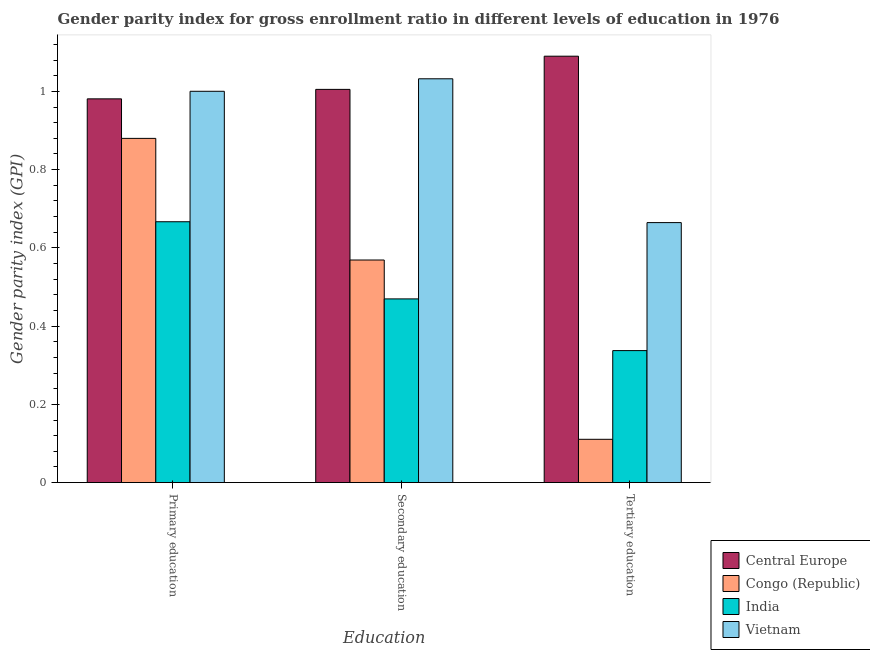Are the number of bars on each tick of the X-axis equal?
Make the answer very short. Yes. How many bars are there on the 1st tick from the right?
Offer a very short reply. 4. What is the label of the 3rd group of bars from the left?
Make the answer very short. Tertiary education. What is the gender parity index in tertiary education in Central Europe?
Ensure brevity in your answer.  1.09. Across all countries, what is the maximum gender parity index in tertiary education?
Make the answer very short. 1.09. Across all countries, what is the minimum gender parity index in primary education?
Offer a terse response. 0.67. In which country was the gender parity index in primary education maximum?
Provide a short and direct response. Vietnam. In which country was the gender parity index in secondary education minimum?
Your answer should be very brief. India. What is the total gender parity index in tertiary education in the graph?
Make the answer very short. 2.2. What is the difference between the gender parity index in tertiary education in Central Europe and that in Congo (Republic)?
Your answer should be very brief. 0.98. What is the difference between the gender parity index in secondary education in Congo (Republic) and the gender parity index in primary education in India?
Provide a succinct answer. -0.1. What is the average gender parity index in primary education per country?
Provide a short and direct response. 0.88. What is the difference between the gender parity index in tertiary education and gender parity index in secondary education in Congo (Republic)?
Provide a succinct answer. -0.46. In how many countries, is the gender parity index in tertiary education greater than 0.32 ?
Ensure brevity in your answer.  3. What is the ratio of the gender parity index in secondary education in Vietnam to that in Central Europe?
Your answer should be very brief. 1.03. What is the difference between the highest and the second highest gender parity index in tertiary education?
Your answer should be very brief. 0.43. What is the difference between the highest and the lowest gender parity index in secondary education?
Your response must be concise. 0.56. In how many countries, is the gender parity index in tertiary education greater than the average gender parity index in tertiary education taken over all countries?
Your response must be concise. 2. What does the 1st bar from the left in Tertiary education represents?
Provide a succinct answer. Central Europe. How many bars are there?
Keep it short and to the point. 12. How many countries are there in the graph?
Your response must be concise. 4. What is the difference between two consecutive major ticks on the Y-axis?
Offer a terse response. 0.2. What is the title of the graph?
Make the answer very short. Gender parity index for gross enrollment ratio in different levels of education in 1976. Does "Burundi" appear as one of the legend labels in the graph?
Offer a terse response. No. What is the label or title of the X-axis?
Offer a terse response. Education. What is the label or title of the Y-axis?
Your answer should be compact. Gender parity index (GPI). What is the Gender parity index (GPI) in Central Europe in Primary education?
Offer a terse response. 0.98. What is the Gender parity index (GPI) in Congo (Republic) in Primary education?
Provide a succinct answer. 0.88. What is the Gender parity index (GPI) in India in Primary education?
Make the answer very short. 0.67. What is the Gender parity index (GPI) of Vietnam in Primary education?
Make the answer very short. 1. What is the Gender parity index (GPI) in Central Europe in Secondary education?
Ensure brevity in your answer.  1.01. What is the Gender parity index (GPI) of Congo (Republic) in Secondary education?
Provide a short and direct response. 0.57. What is the Gender parity index (GPI) in India in Secondary education?
Provide a succinct answer. 0.47. What is the Gender parity index (GPI) of Vietnam in Secondary education?
Give a very brief answer. 1.03. What is the Gender parity index (GPI) in Central Europe in Tertiary education?
Keep it short and to the point. 1.09. What is the Gender parity index (GPI) in Congo (Republic) in Tertiary education?
Provide a succinct answer. 0.11. What is the Gender parity index (GPI) in India in Tertiary education?
Provide a succinct answer. 0.34. What is the Gender parity index (GPI) in Vietnam in Tertiary education?
Your response must be concise. 0.66. Across all Education, what is the maximum Gender parity index (GPI) in Central Europe?
Give a very brief answer. 1.09. Across all Education, what is the maximum Gender parity index (GPI) in Congo (Republic)?
Provide a short and direct response. 0.88. Across all Education, what is the maximum Gender parity index (GPI) of India?
Provide a short and direct response. 0.67. Across all Education, what is the maximum Gender parity index (GPI) of Vietnam?
Your answer should be very brief. 1.03. Across all Education, what is the minimum Gender parity index (GPI) in Central Europe?
Make the answer very short. 0.98. Across all Education, what is the minimum Gender parity index (GPI) in Congo (Republic)?
Give a very brief answer. 0.11. Across all Education, what is the minimum Gender parity index (GPI) of India?
Provide a short and direct response. 0.34. Across all Education, what is the minimum Gender parity index (GPI) in Vietnam?
Provide a short and direct response. 0.66. What is the total Gender parity index (GPI) in Central Europe in the graph?
Your answer should be compact. 3.08. What is the total Gender parity index (GPI) in Congo (Republic) in the graph?
Make the answer very short. 1.56. What is the total Gender parity index (GPI) in India in the graph?
Give a very brief answer. 1.47. What is the total Gender parity index (GPI) of Vietnam in the graph?
Keep it short and to the point. 2.7. What is the difference between the Gender parity index (GPI) in Central Europe in Primary education and that in Secondary education?
Your answer should be compact. -0.02. What is the difference between the Gender parity index (GPI) in Congo (Republic) in Primary education and that in Secondary education?
Offer a very short reply. 0.31. What is the difference between the Gender parity index (GPI) in India in Primary education and that in Secondary education?
Provide a succinct answer. 0.2. What is the difference between the Gender parity index (GPI) of Vietnam in Primary education and that in Secondary education?
Keep it short and to the point. -0.03. What is the difference between the Gender parity index (GPI) of Central Europe in Primary education and that in Tertiary education?
Offer a terse response. -0.11. What is the difference between the Gender parity index (GPI) in Congo (Republic) in Primary education and that in Tertiary education?
Offer a terse response. 0.77. What is the difference between the Gender parity index (GPI) in India in Primary education and that in Tertiary education?
Offer a terse response. 0.33. What is the difference between the Gender parity index (GPI) of Vietnam in Primary education and that in Tertiary education?
Your response must be concise. 0.34. What is the difference between the Gender parity index (GPI) of Central Europe in Secondary education and that in Tertiary education?
Provide a short and direct response. -0.08. What is the difference between the Gender parity index (GPI) in Congo (Republic) in Secondary education and that in Tertiary education?
Your response must be concise. 0.46. What is the difference between the Gender parity index (GPI) in India in Secondary education and that in Tertiary education?
Offer a very short reply. 0.13. What is the difference between the Gender parity index (GPI) of Vietnam in Secondary education and that in Tertiary education?
Your response must be concise. 0.37. What is the difference between the Gender parity index (GPI) in Central Europe in Primary education and the Gender parity index (GPI) in Congo (Republic) in Secondary education?
Provide a succinct answer. 0.41. What is the difference between the Gender parity index (GPI) in Central Europe in Primary education and the Gender parity index (GPI) in India in Secondary education?
Provide a succinct answer. 0.51. What is the difference between the Gender parity index (GPI) in Central Europe in Primary education and the Gender parity index (GPI) in Vietnam in Secondary education?
Provide a short and direct response. -0.05. What is the difference between the Gender parity index (GPI) in Congo (Republic) in Primary education and the Gender parity index (GPI) in India in Secondary education?
Give a very brief answer. 0.41. What is the difference between the Gender parity index (GPI) of Congo (Republic) in Primary education and the Gender parity index (GPI) of Vietnam in Secondary education?
Provide a short and direct response. -0.15. What is the difference between the Gender parity index (GPI) of India in Primary education and the Gender parity index (GPI) of Vietnam in Secondary education?
Offer a terse response. -0.37. What is the difference between the Gender parity index (GPI) of Central Europe in Primary education and the Gender parity index (GPI) of Congo (Republic) in Tertiary education?
Your answer should be very brief. 0.87. What is the difference between the Gender parity index (GPI) of Central Europe in Primary education and the Gender parity index (GPI) of India in Tertiary education?
Offer a terse response. 0.64. What is the difference between the Gender parity index (GPI) of Central Europe in Primary education and the Gender parity index (GPI) of Vietnam in Tertiary education?
Your answer should be very brief. 0.32. What is the difference between the Gender parity index (GPI) in Congo (Republic) in Primary education and the Gender parity index (GPI) in India in Tertiary education?
Keep it short and to the point. 0.54. What is the difference between the Gender parity index (GPI) of Congo (Republic) in Primary education and the Gender parity index (GPI) of Vietnam in Tertiary education?
Provide a succinct answer. 0.22. What is the difference between the Gender parity index (GPI) of India in Primary education and the Gender parity index (GPI) of Vietnam in Tertiary education?
Provide a short and direct response. 0. What is the difference between the Gender parity index (GPI) in Central Europe in Secondary education and the Gender parity index (GPI) in Congo (Republic) in Tertiary education?
Offer a terse response. 0.89. What is the difference between the Gender parity index (GPI) of Central Europe in Secondary education and the Gender parity index (GPI) of India in Tertiary education?
Provide a short and direct response. 0.67. What is the difference between the Gender parity index (GPI) in Central Europe in Secondary education and the Gender parity index (GPI) in Vietnam in Tertiary education?
Make the answer very short. 0.34. What is the difference between the Gender parity index (GPI) of Congo (Republic) in Secondary education and the Gender parity index (GPI) of India in Tertiary education?
Offer a very short reply. 0.23. What is the difference between the Gender parity index (GPI) in Congo (Republic) in Secondary education and the Gender parity index (GPI) in Vietnam in Tertiary education?
Give a very brief answer. -0.1. What is the difference between the Gender parity index (GPI) of India in Secondary education and the Gender parity index (GPI) of Vietnam in Tertiary education?
Provide a short and direct response. -0.2. What is the average Gender parity index (GPI) of Central Europe per Education?
Offer a very short reply. 1.03. What is the average Gender parity index (GPI) in Congo (Republic) per Education?
Provide a short and direct response. 0.52. What is the average Gender parity index (GPI) in India per Education?
Give a very brief answer. 0.49. What is the average Gender parity index (GPI) of Vietnam per Education?
Your answer should be very brief. 0.9. What is the difference between the Gender parity index (GPI) in Central Europe and Gender parity index (GPI) in Congo (Republic) in Primary education?
Ensure brevity in your answer.  0.1. What is the difference between the Gender parity index (GPI) in Central Europe and Gender parity index (GPI) in India in Primary education?
Offer a terse response. 0.31. What is the difference between the Gender parity index (GPI) of Central Europe and Gender parity index (GPI) of Vietnam in Primary education?
Your response must be concise. -0.02. What is the difference between the Gender parity index (GPI) of Congo (Republic) and Gender parity index (GPI) of India in Primary education?
Your answer should be compact. 0.21. What is the difference between the Gender parity index (GPI) of Congo (Republic) and Gender parity index (GPI) of Vietnam in Primary education?
Give a very brief answer. -0.12. What is the difference between the Gender parity index (GPI) in India and Gender parity index (GPI) in Vietnam in Primary education?
Your answer should be very brief. -0.33. What is the difference between the Gender parity index (GPI) of Central Europe and Gender parity index (GPI) of Congo (Republic) in Secondary education?
Provide a short and direct response. 0.44. What is the difference between the Gender parity index (GPI) in Central Europe and Gender parity index (GPI) in India in Secondary education?
Provide a short and direct response. 0.54. What is the difference between the Gender parity index (GPI) of Central Europe and Gender parity index (GPI) of Vietnam in Secondary education?
Keep it short and to the point. -0.03. What is the difference between the Gender parity index (GPI) in Congo (Republic) and Gender parity index (GPI) in India in Secondary education?
Keep it short and to the point. 0.1. What is the difference between the Gender parity index (GPI) of Congo (Republic) and Gender parity index (GPI) of Vietnam in Secondary education?
Your answer should be very brief. -0.46. What is the difference between the Gender parity index (GPI) in India and Gender parity index (GPI) in Vietnam in Secondary education?
Provide a succinct answer. -0.56. What is the difference between the Gender parity index (GPI) in Central Europe and Gender parity index (GPI) in Congo (Republic) in Tertiary education?
Give a very brief answer. 0.98. What is the difference between the Gender parity index (GPI) of Central Europe and Gender parity index (GPI) of India in Tertiary education?
Provide a succinct answer. 0.75. What is the difference between the Gender parity index (GPI) in Central Europe and Gender parity index (GPI) in Vietnam in Tertiary education?
Your answer should be very brief. 0.43. What is the difference between the Gender parity index (GPI) in Congo (Republic) and Gender parity index (GPI) in India in Tertiary education?
Give a very brief answer. -0.23. What is the difference between the Gender parity index (GPI) in Congo (Republic) and Gender parity index (GPI) in Vietnam in Tertiary education?
Offer a terse response. -0.55. What is the difference between the Gender parity index (GPI) in India and Gender parity index (GPI) in Vietnam in Tertiary education?
Ensure brevity in your answer.  -0.33. What is the ratio of the Gender parity index (GPI) of Central Europe in Primary education to that in Secondary education?
Make the answer very short. 0.98. What is the ratio of the Gender parity index (GPI) of Congo (Republic) in Primary education to that in Secondary education?
Make the answer very short. 1.55. What is the ratio of the Gender parity index (GPI) of India in Primary education to that in Secondary education?
Your response must be concise. 1.42. What is the ratio of the Gender parity index (GPI) of Vietnam in Primary education to that in Secondary education?
Provide a succinct answer. 0.97. What is the ratio of the Gender parity index (GPI) in Central Europe in Primary education to that in Tertiary education?
Your answer should be compact. 0.9. What is the ratio of the Gender parity index (GPI) in Congo (Republic) in Primary education to that in Tertiary education?
Give a very brief answer. 7.95. What is the ratio of the Gender parity index (GPI) of India in Primary education to that in Tertiary education?
Provide a short and direct response. 1.98. What is the ratio of the Gender parity index (GPI) in Vietnam in Primary education to that in Tertiary education?
Your answer should be compact. 1.51. What is the ratio of the Gender parity index (GPI) in Central Europe in Secondary education to that in Tertiary education?
Your answer should be compact. 0.92. What is the ratio of the Gender parity index (GPI) in Congo (Republic) in Secondary education to that in Tertiary education?
Keep it short and to the point. 5.14. What is the ratio of the Gender parity index (GPI) in India in Secondary education to that in Tertiary education?
Provide a succinct answer. 1.39. What is the ratio of the Gender parity index (GPI) of Vietnam in Secondary education to that in Tertiary education?
Your answer should be very brief. 1.55. What is the difference between the highest and the second highest Gender parity index (GPI) in Central Europe?
Offer a terse response. 0.08. What is the difference between the highest and the second highest Gender parity index (GPI) of Congo (Republic)?
Your response must be concise. 0.31. What is the difference between the highest and the second highest Gender parity index (GPI) of India?
Give a very brief answer. 0.2. What is the difference between the highest and the second highest Gender parity index (GPI) in Vietnam?
Offer a terse response. 0.03. What is the difference between the highest and the lowest Gender parity index (GPI) in Central Europe?
Offer a very short reply. 0.11. What is the difference between the highest and the lowest Gender parity index (GPI) of Congo (Republic)?
Make the answer very short. 0.77. What is the difference between the highest and the lowest Gender parity index (GPI) in India?
Your response must be concise. 0.33. What is the difference between the highest and the lowest Gender parity index (GPI) of Vietnam?
Provide a succinct answer. 0.37. 